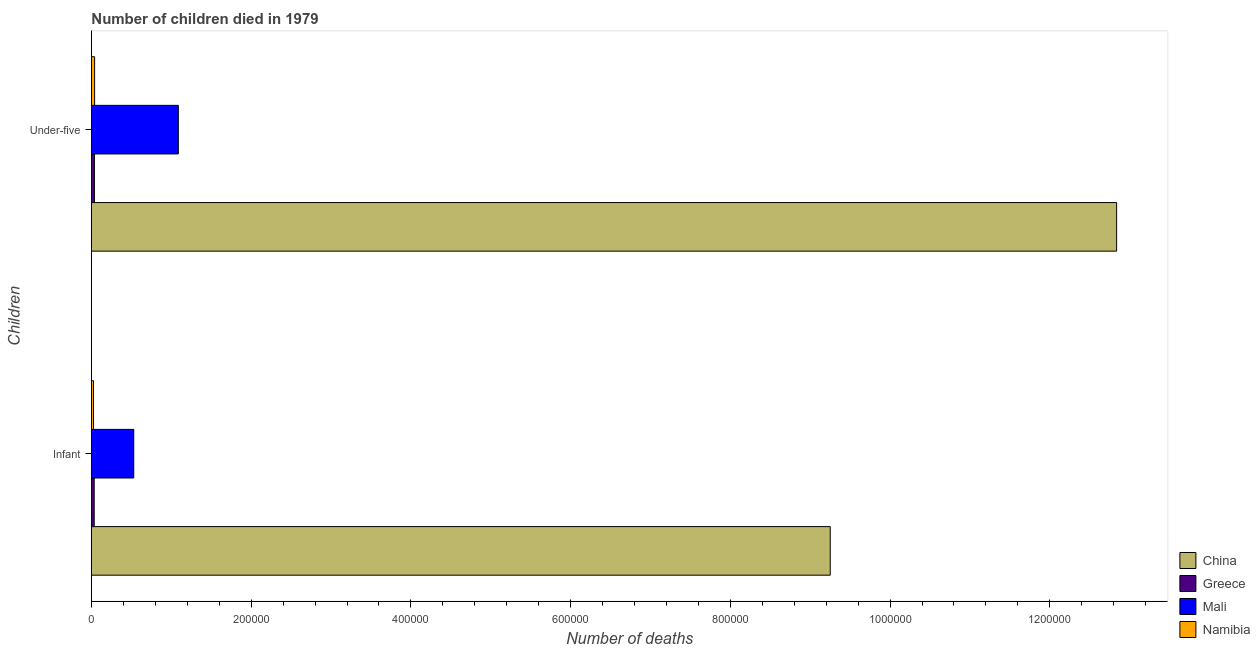How many different coloured bars are there?
Offer a very short reply. 4. What is the label of the 2nd group of bars from the top?
Your answer should be very brief. Infant. What is the number of infant deaths in China?
Your answer should be compact. 9.25e+05. Across all countries, what is the maximum number of infant deaths?
Your answer should be compact. 9.25e+05. Across all countries, what is the minimum number of under-five deaths?
Your answer should be compact. 3809. In which country was the number of under-five deaths minimum?
Offer a terse response. Greece. What is the total number of infant deaths in the graph?
Your answer should be compact. 9.84e+05. What is the difference between the number of infant deaths in Greece and that in Mali?
Ensure brevity in your answer.  -4.95e+04. What is the difference between the number of infant deaths in Mali and the number of under-five deaths in China?
Your answer should be very brief. -1.23e+06. What is the average number of infant deaths per country?
Your answer should be compact. 2.46e+05. What is the difference between the number of infant deaths and number of under-five deaths in Mali?
Make the answer very short. -5.58e+04. What is the ratio of the number of infant deaths in China to that in Namibia?
Provide a succinct answer. 354.15. In how many countries, is the number of under-five deaths greater than the average number of under-five deaths taken over all countries?
Give a very brief answer. 1. What does the 3rd bar from the top in Infant represents?
Your answer should be very brief. Greece. What does the 4th bar from the bottom in Under-five represents?
Provide a succinct answer. Namibia. How many bars are there?
Provide a short and direct response. 8. Are all the bars in the graph horizontal?
Your answer should be compact. Yes. How many countries are there in the graph?
Offer a terse response. 4. Are the values on the major ticks of X-axis written in scientific E-notation?
Provide a succinct answer. No. Does the graph contain grids?
Your response must be concise. No. How many legend labels are there?
Make the answer very short. 4. How are the legend labels stacked?
Provide a succinct answer. Vertical. What is the title of the graph?
Your answer should be compact. Number of children died in 1979. Does "South Sudan" appear as one of the legend labels in the graph?
Your answer should be compact. No. What is the label or title of the X-axis?
Provide a succinct answer. Number of deaths. What is the label or title of the Y-axis?
Give a very brief answer. Children. What is the Number of deaths of China in Infant?
Keep it short and to the point. 9.25e+05. What is the Number of deaths in Greece in Infant?
Your response must be concise. 3484. What is the Number of deaths in Mali in Infant?
Provide a succinct answer. 5.30e+04. What is the Number of deaths of Namibia in Infant?
Provide a succinct answer. 2612. What is the Number of deaths in China in Under-five?
Your response must be concise. 1.28e+06. What is the Number of deaths of Greece in Under-five?
Keep it short and to the point. 3809. What is the Number of deaths of Mali in Under-five?
Your answer should be very brief. 1.09e+05. What is the Number of deaths in Namibia in Under-five?
Offer a terse response. 3992. Across all Children, what is the maximum Number of deaths in China?
Give a very brief answer. 1.28e+06. Across all Children, what is the maximum Number of deaths in Greece?
Your answer should be compact. 3809. Across all Children, what is the maximum Number of deaths of Mali?
Provide a succinct answer. 1.09e+05. Across all Children, what is the maximum Number of deaths in Namibia?
Give a very brief answer. 3992. Across all Children, what is the minimum Number of deaths in China?
Your answer should be very brief. 9.25e+05. Across all Children, what is the minimum Number of deaths in Greece?
Your answer should be very brief. 3484. Across all Children, what is the minimum Number of deaths in Mali?
Your answer should be very brief. 5.30e+04. Across all Children, what is the minimum Number of deaths in Namibia?
Your response must be concise. 2612. What is the total Number of deaths in China in the graph?
Provide a succinct answer. 2.21e+06. What is the total Number of deaths in Greece in the graph?
Provide a short and direct response. 7293. What is the total Number of deaths in Mali in the graph?
Your response must be concise. 1.62e+05. What is the total Number of deaths of Namibia in the graph?
Provide a short and direct response. 6604. What is the difference between the Number of deaths in China in Infant and that in Under-five?
Ensure brevity in your answer.  -3.59e+05. What is the difference between the Number of deaths of Greece in Infant and that in Under-five?
Make the answer very short. -325. What is the difference between the Number of deaths of Mali in Infant and that in Under-five?
Your response must be concise. -5.58e+04. What is the difference between the Number of deaths in Namibia in Infant and that in Under-five?
Provide a short and direct response. -1380. What is the difference between the Number of deaths in China in Infant and the Number of deaths in Greece in Under-five?
Offer a terse response. 9.21e+05. What is the difference between the Number of deaths in China in Infant and the Number of deaths in Mali in Under-five?
Your response must be concise. 8.16e+05. What is the difference between the Number of deaths of China in Infant and the Number of deaths of Namibia in Under-five?
Ensure brevity in your answer.  9.21e+05. What is the difference between the Number of deaths of Greece in Infant and the Number of deaths of Mali in Under-five?
Your answer should be compact. -1.05e+05. What is the difference between the Number of deaths in Greece in Infant and the Number of deaths in Namibia in Under-five?
Give a very brief answer. -508. What is the difference between the Number of deaths in Mali in Infant and the Number of deaths in Namibia in Under-five?
Make the answer very short. 4.90e+04. What is the average Number of deaths of China per Children?
Provide a succinct answer. 1.10e+06. What is the average Number of deaths in Greece per Children?
Your answer should be compact. 3646.5. What is the average Number of deaths in Mali per Children?
Your answer should be compact. 8.09e+04. What is the average Number of deaths in Namibia per Children?
Provide a succinct answer. 3302. What is the difference between the Number of deaths of China and Number of deaths of Greece in Infant?
Your answer should be very brief. 9.22e+05. What is the difference between the Number of deaths in China and Number of deaths in Mali in Infant?
Your answer should be very brief. 8.72e+05. What is the difference between the Number of deaths in China and Number of deaths in Namibia in Infant?
Your answer should be very brief. 9.22e+05. What is the difference between the Number of deaths in Greece and Number of deaths in Mali in Infant?
Provide a succinct answer. -4.95e+04. What is the difference between the Number of deaths of Greece and Number of deaths of Namibia in Infant?
Offer a terse response. 872. What is the difference between the Number of deaths of Mali and Number of deaths of Namibia in Infant?
Offer a very short reply. 5.04e+04. What is the difference between the Number of deaths in China and Number of deaths in Greece in Under-five?
Provide a succinct answer. 1.28e+06. What is the difference between the Number of deaths in China and Number of deaths in Mali in Under-five?
Make the answer very short. 1.17e+06. What is the difference between the Number of deaths of China and Number of deaths of Namibia in Under-five?
Offer a terse response. 1.28e+06. What is the difference between the Number of deaths in Greece and Number of deaths in Mali in Under-five?
Make the answer very short. -1.05e+05. What is the difference between the Number of deaths of Greece and Number of deaths of Namibia in Under-five?
Your answer should be very brief. -183. What is the difference between the Number of deaths in Mali and Number of deaths in Namibia in Under-five?
Make the answer very short. 1.05e+05. What is the ratio of the Number of deaths of China in Infant to that in Under-five?
Offer a very short reply. 0.72. What is the ratio of the Number of deaths in Greece in Infant to that in Under-five?
Your answer should be very brief. 0.91. What is the ratio of the Number of deaths in Mali in Infant to that in Under-five?
Your answer should be compact. 0.49. What is the ratio of the Number of deaths of Namibia in Infant to that in Under-five?
Your answer should be very brief. 0.65. What is the difference between the highest and the second highest Number of deaths of China?
Your response must be concise. 3.59e+05. What is the difference between the highest and the second highest Number of deaths in Greece?
Offer a terse response. 325. What is the difference between the highest and the second highest Number of deaths in Mali?
Your answer should be very brief. 5.58e+04. What is the difference between the highest and the second highest Number of deaths of Namibia?
Your answer should be compact. 1380. What is the difference between the highest and the lowest Number of deaths of China?
Your response must be concise. 3.59e+05. What is the difference between the highest and the lowest Number of deaths of Greece?
Your answer should be compact. 325. What is the difference between the highest and the lowest Number of deaths in Mali?
Provide a succinct answer. 5.58e+04. What is the difference between the highest and the lowest Number of deaths of Namibia?
Your response must be concise. 1380. 